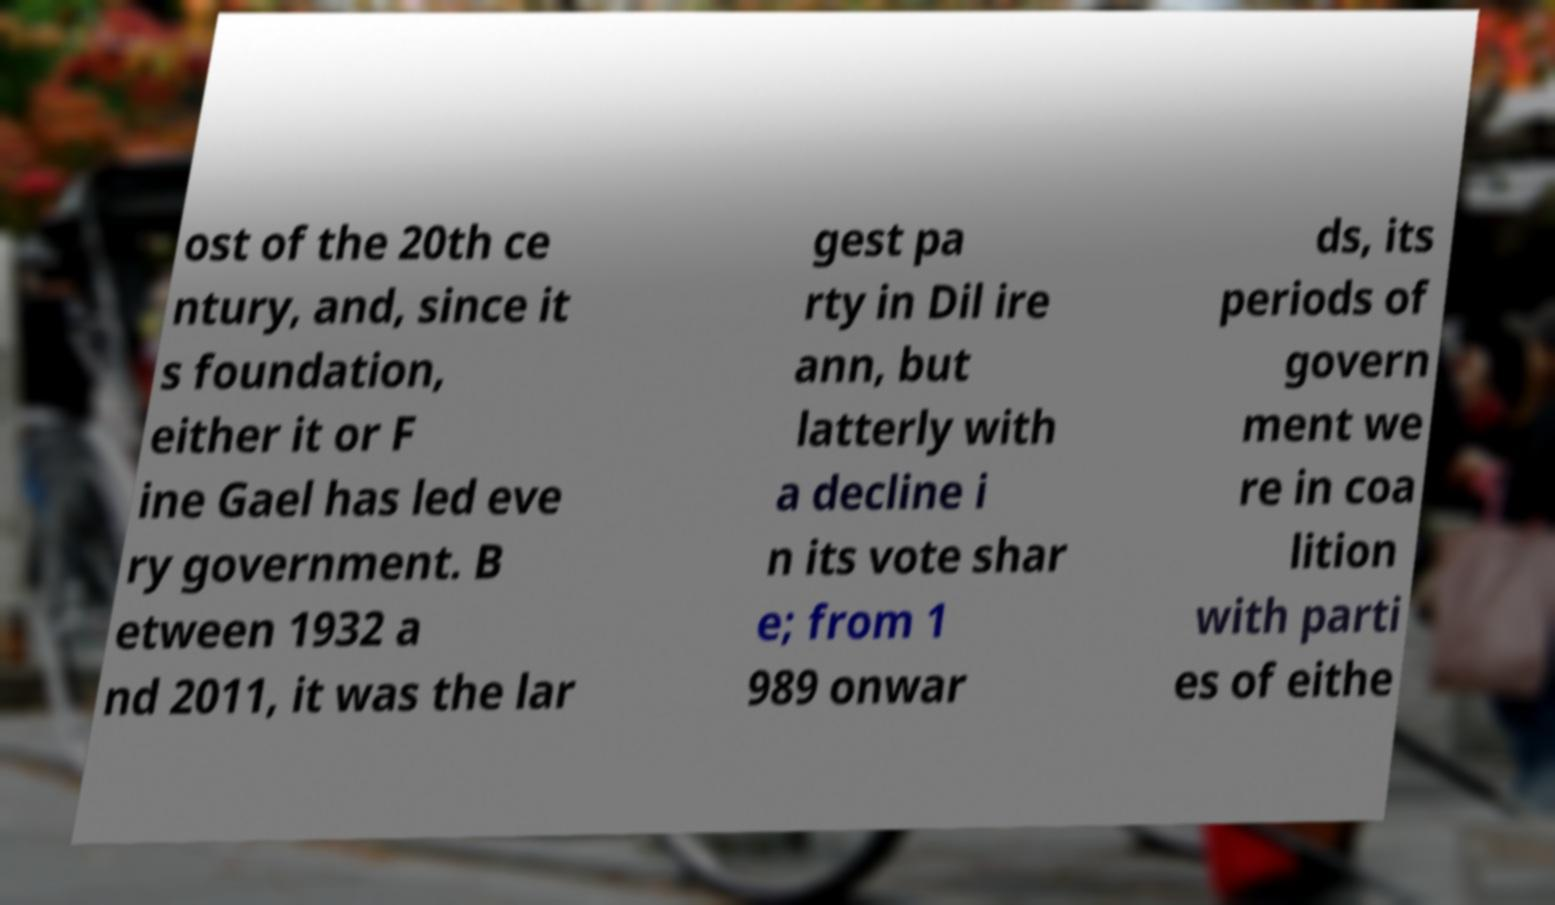For documentation purposes, I need the text within this image transcribed. Could you provide that? ost of the 20th ce ntury, and, since it s foundation, either it or F ine Gael has led eve ry government. B etween 1932 a nd 2011, it was the lar gest pa rty in Dil ire ann, but latterly with a decline i n its vote shar e; from 1 989 onwar ds, its periods of govern ment we re in coa lition with parti es of eithe 